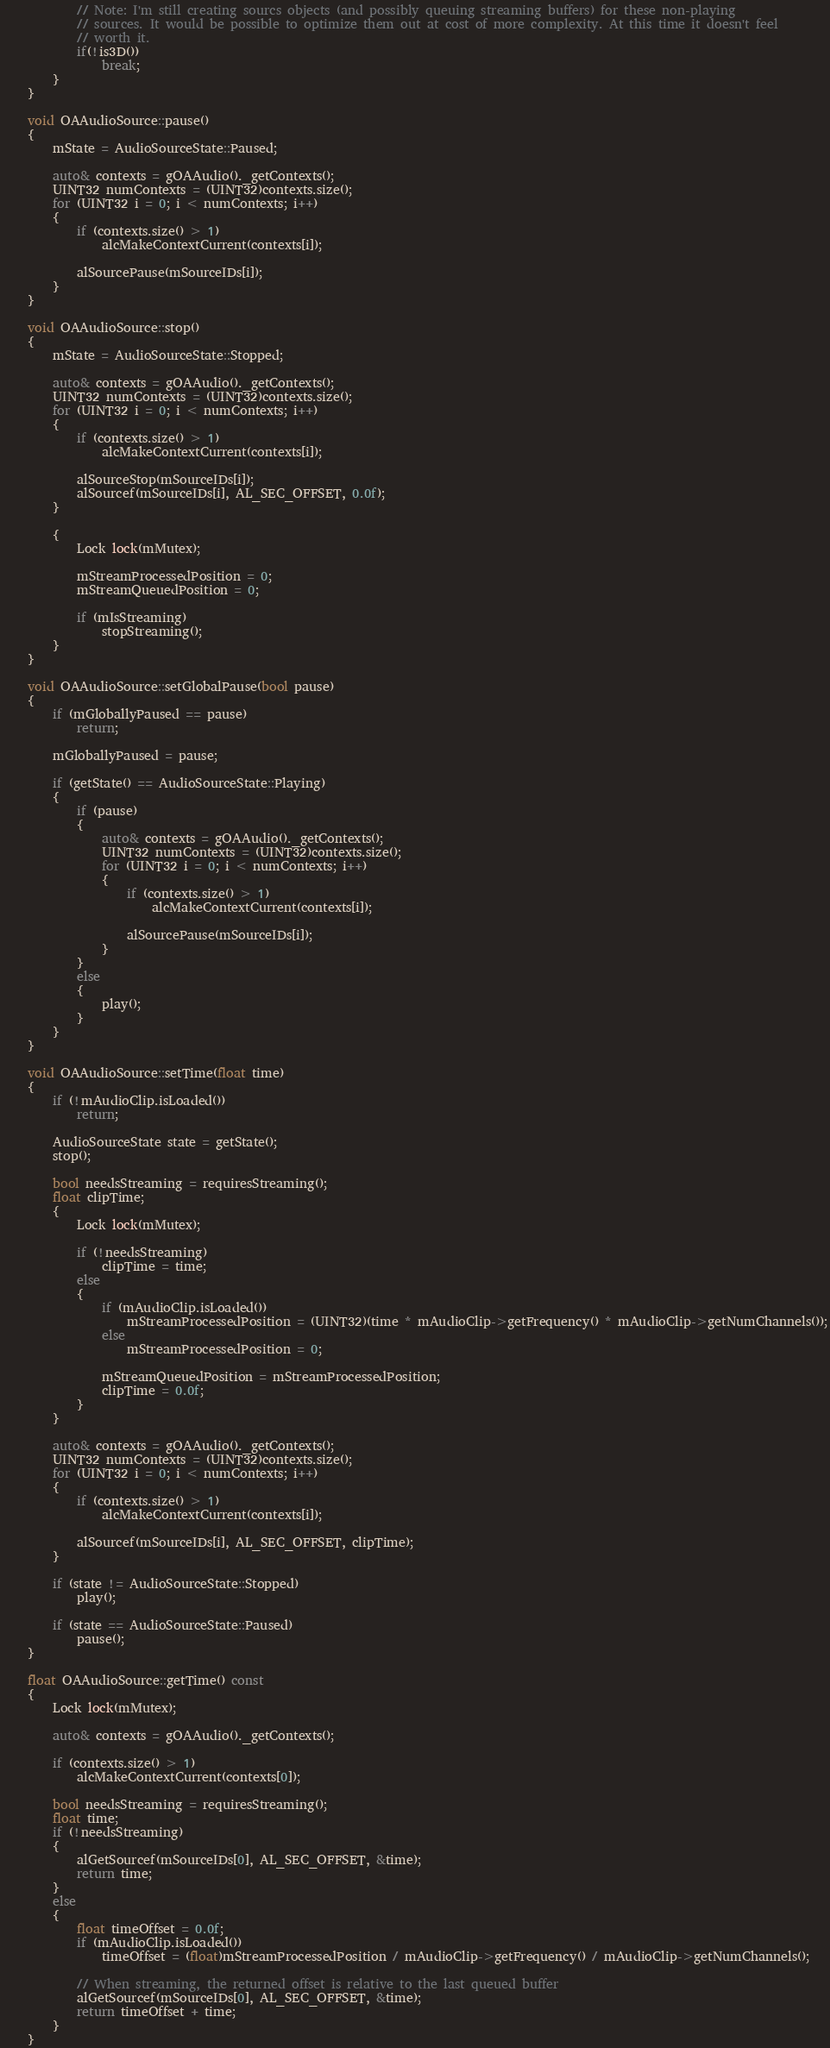Convert code to text. <code><loc_0><loc_0><loc_500><loc_500><_C++_>			// Note: I'm still creating sourcs objects (and possibly queuing streaming buffers) for these non-playing 
			// sources. It would be possible to optimize them out at cost of more complexity. At this time it doesn't feel
			// worth it.
			if(!is3D()) 
				break;
		}
	}

	void OAAudioSource::pause()
	{
		mState = AudioSourceState::Paused;

		auto& contexts = gOAAudio()._getContexts();
		UINT32 numContexts = (UINT32)contexts.size();
		for (UINT32 i = 0; i < numContexts; i++)
		{
			if (contexts.size() > 1)
				alcMakeContextCurrent(contexts[i]);

			alSourcePause(mSourceIDs[i]);
		}
	}

	void OAAudioSource::stop()
	{
		mState = AudioSourceState::Stopped;

		auto& contexts = gOAAudio()._getContexts();
		UINT32 numContexts = (UINT32)contexts.size();
		for (UINT32 i = 0; i < numContexts; i++)
		{
			if (contexts.size() > 1)
				alcMakeContextCurrent(contexts[i]);

			alSourceStop(mSourceIDs[i]);
			alSourcef(mSourceIDs[i], AL_SEC_OFFSET, 0.0f);
		}

		{
			Lock lock(mMutex);

			mStreamProcessedPosition = 0;
			mStreamQueuedPosition = 0;

			if (mIsStreaming)
				stopStreaming();
		}
	}

	void OAAudioSource::setGlobalPause(bool pause)
	{
		if (mGloballyPaused == pause)
			return;

		mGloballyPaused = pause;

		if (getState() == AudioSourceState::Playing)
		{
			if (pause)
			{
				auto& contexts = gOAAudio()._getContexts();
				UINT32 numContexts = (UINT32)contexts.size();
				for (UINT32 i = 0; i < numContexts; i++)
				{
					if (contexts.size() > 1)
						alcMakeContextCurrent(contexts[i]);

					alSourcePause(mSourceIDs[i]);
				}
			}
			else
			{
				play();
			}
		}
	}

	void OAAudioSource::setTime(float time)
	{
		if (!mAudioClip.isLoaded())
			return;

		AudioSourceState state = getState();
		stop();

		bool needsStreaming = requiresStreaming();
		float clipTime;
		{
			Lock lock(mMutex);

			if (!needsStreaming)
				clipTime = time;
			else
			{
				if (mAudioClip.isLoaded())
					mStreamProcessedPosition = (UINT32)(time * mAudioClip->getFrequency() * mAudioClip->getNumChannels());
				else
					mStreamProcessedPosition = 0;

				mStreamQueuedPosition = mStreamProcessedPosition;
				clipTime = 0.0f;
			}
		}

		auto& contexts = gOAAudio()._getContexts();
		UINT32 numContexts = (UINT32)contexts.size();
		for (UINT32 i = 0; i < numContexts; i++)
		{
			if (contexts.size() > 1)
				alcMakeContextCurrent(contexts[i]);

			alSourcef(mSourceIDs[i], AL_SEC_OFFSET, clipTime);
		}

		if (state != AudioSourceState::Stopped)
			play();
		
		if (state == AudioSourceState::Paused)
			pause();
	}

	float OAAudioSource::getTime() const
	{
		Lock lock(mMutex);

		auto& contexts = gOAAudio()._getContexts();

		if (contexts.size() > 1)
			alcMakeContextCurrent(contexts[0]);

		bool needsStreaming = requiresStreaming();
		float time;
		if (!needsStreaming)
		{
			alGetSourcef(mSourceIDs[0], AL_SEC_OFFSET, &time);
			return time;
		}
		else
		{
			float timeOffset = 0.0f;
			if (mAudioClip.isLoaded())
				timeOffset = (float)mStreamProcessedPosition / mAudioClip->getFrequency() / mAudioClip->getNumChannels();

			// When streaming, the returned offset is relative to the last queued buffer
			alGetSourcef(mSourceIDs[0], AL_SEC_OFFSET, &time);
			return timeOffset + time;
		}
	}
</code> 